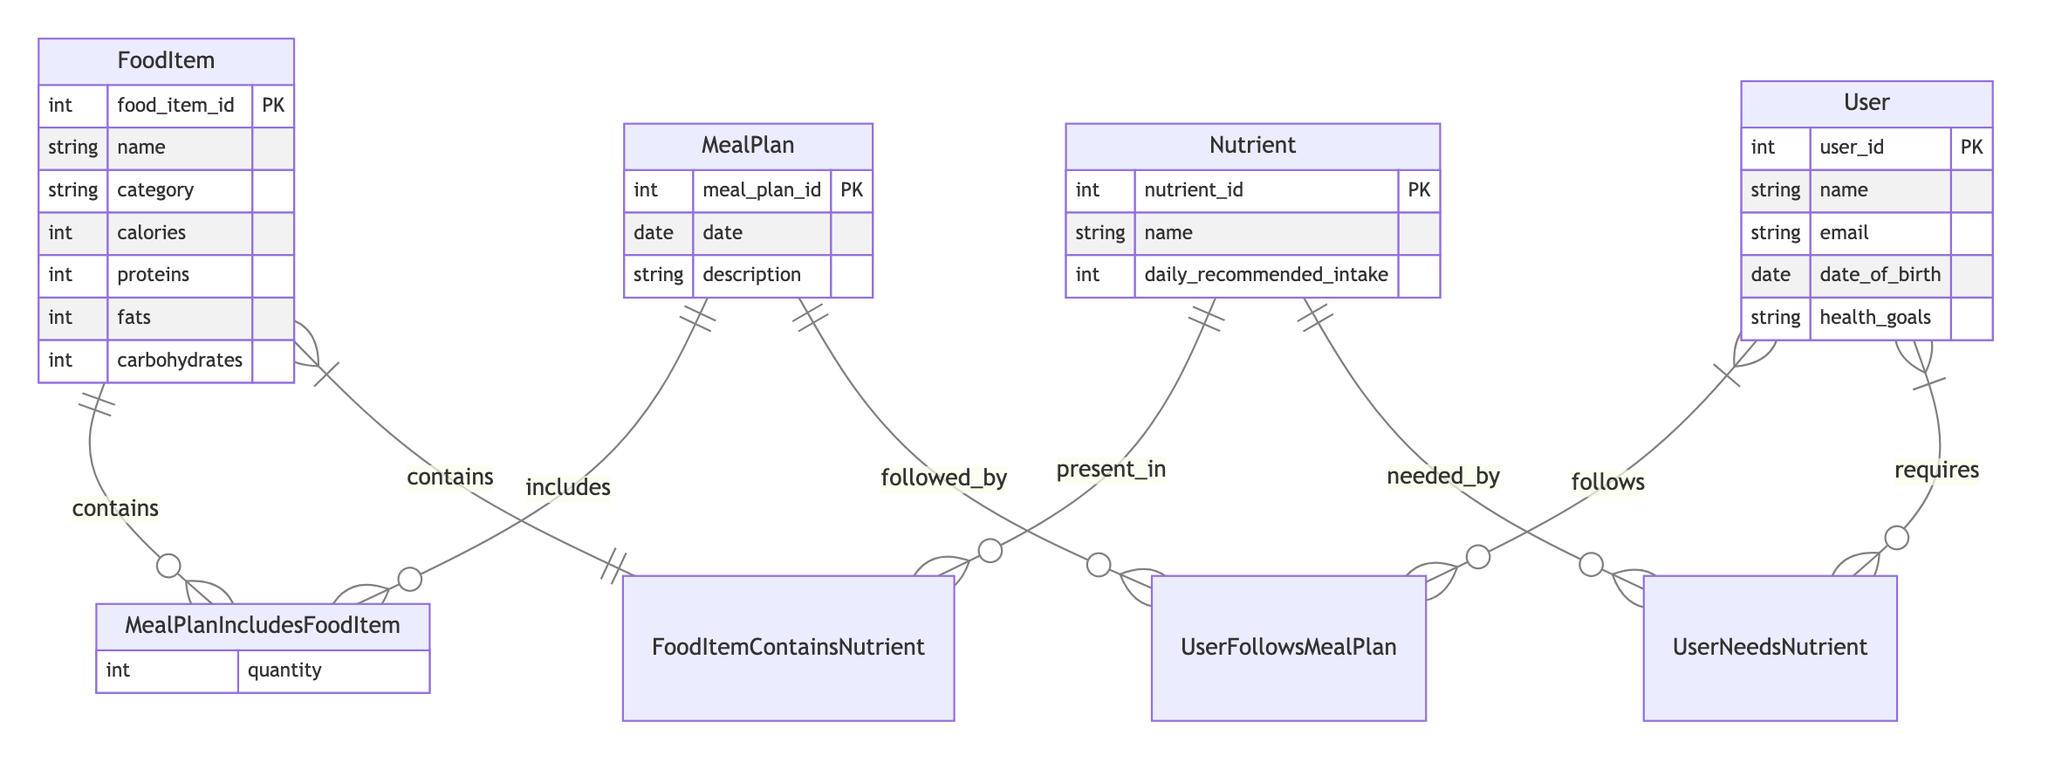What are the primary entities in the diagram? The diagram includes four primary entities: FoodItem, MealPlan, Nutrient, and User. Each entity is depicted with its attributes, indicating the main components of the nutritional tracking system.
Answer: FoodItem, MealPlan, Nutrient, User How many attributes does the Nutrient entity have? The Nutrient entity has three attributes: nutrient_id, name, and daily_recommended_intake. Each attribute provides necessary information about the nutrient.
Answer: Three What relationship exists between User and MealPlan? The relationship between User and MealPlan is a many-to-many relationship called UserFollowsMealPlan, indicating that multiple users can follow multiple meal plans.
Answer: Many-to-many What is the name of the relationship that connects FoodItem and Nutrient? The relationship connecting FoodItem and Nutrient is called FoodItemContainsNutrient, which indicates that a food item can contain several different nutrients.
Answer: FoodItemContainsNutrient How is the FoodItem entity related to MealPlan? The FoodItem entity is related to the MealPlan entity through a many-to-many relationship called MealPlanIncludesFoodItem, which denotes that a meal plan can include multiple food items and vice versa.
Answer: Many-to-many What type of relationship is UserNeedsNutrient? UserNeedsNutrient is a many-to-many relationship, which shows that multiple users can need multiple nutrients based on their dietary requirements.
Answer: Many-to-many Which entity has a primary key called user_id? The entity with a primary key called user_id is the User entity, which uniquely identifies each user in the tracking system.
Answer: User What is an attribute of the MealPlan entity? An attribute of the MealPlan entity is "date," which records the specific date associated with the meal plan, indicating when the plan is applicable.
Answer: Date How many entities include a PK attribute? There are four entities that include a primary key attribute: FoodItem, MealPlan, Nutrient, and User. Each entity's primary key uniquely identifies its records in the database.
Answer: Four 